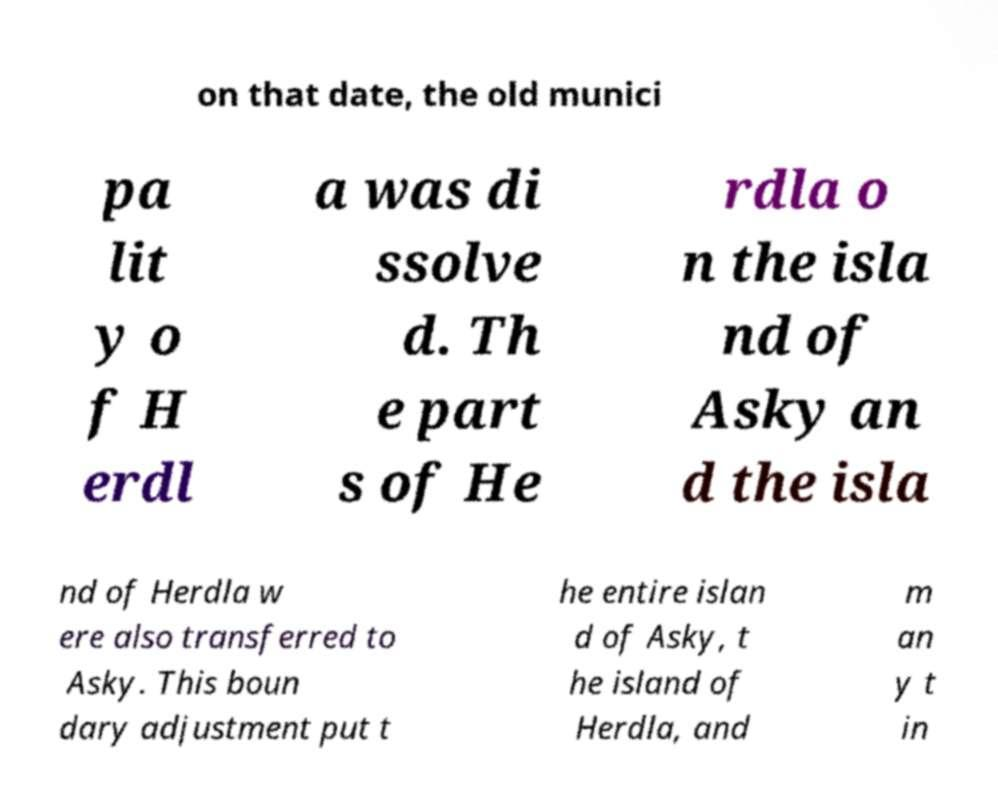Can you accurately transcribe the text from the provided image for me? on that date, the old munici pa lit y o f H erdl a was di ssolve d. Th e part s of He rdla o n the isla nd of Asky an d the isla nd of Herdla w ere also transferred to Asky. This boun dary adjustment put t he entire islan d of Asky, t he island of Herdla, and m an y t in 